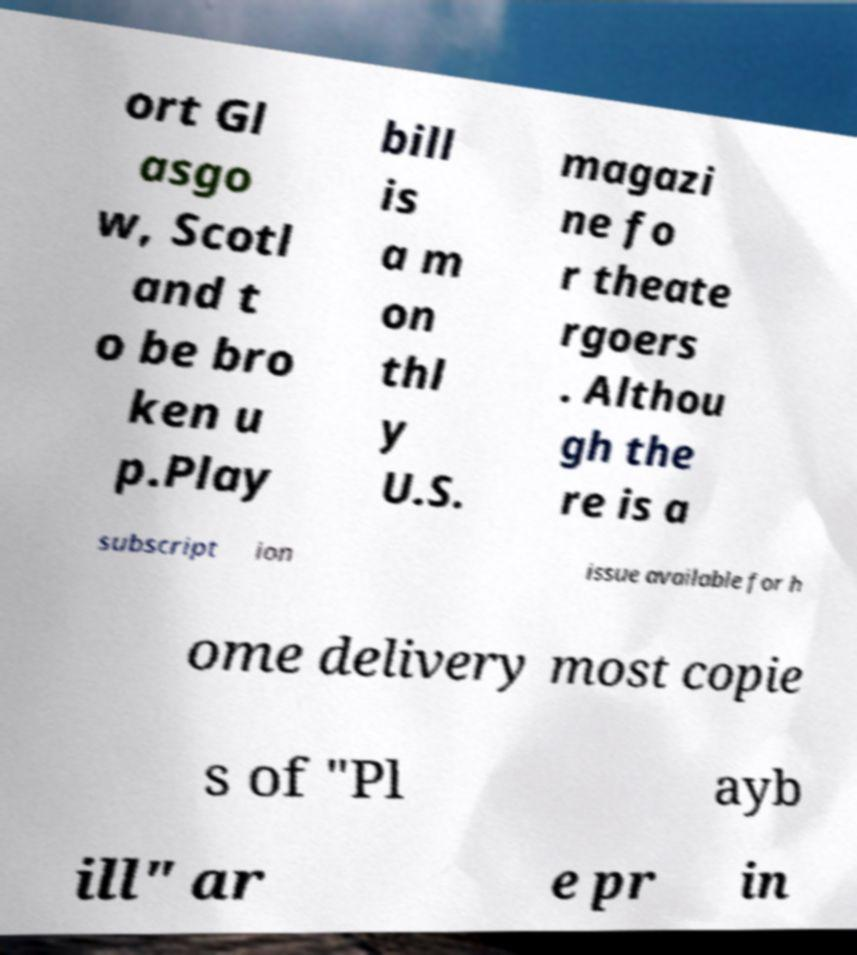For documentation purposes, I need the text within this image transcribed. Could you provide that? ort Gl asgo w, Scotl and t o be bro ken u p.Play bill is a m on thl y U.S. magazi ne fo r theate rgoers . Althou gh the re is a subscript ion issue available for h ome delivery most copie s of "Pl ayb ill" ar e pr in 